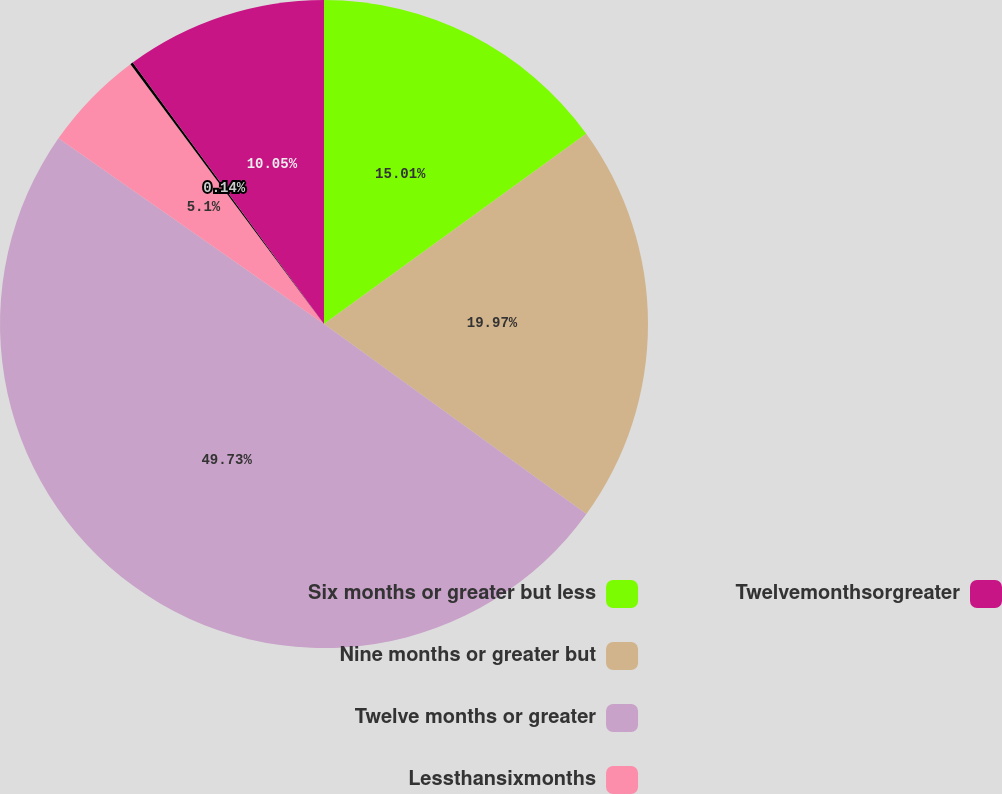Convert chart. <chart><loc_0><loc_0><loc_500><loc_500><pie_chart><fcel>Six months or greater but less<fcel>Nine months or greater but<fcel>Twelve months or greater<fcel>Lessthansixmonths<fcel>Unnamed: 4<fcel>Twelvemonthsorgreater<nl><fcel>15.01%<fcel>19.97%<fcel>49.73%<fcel>5.1%<fcel>0.14%<fcel>10.05%<nl></chart> 